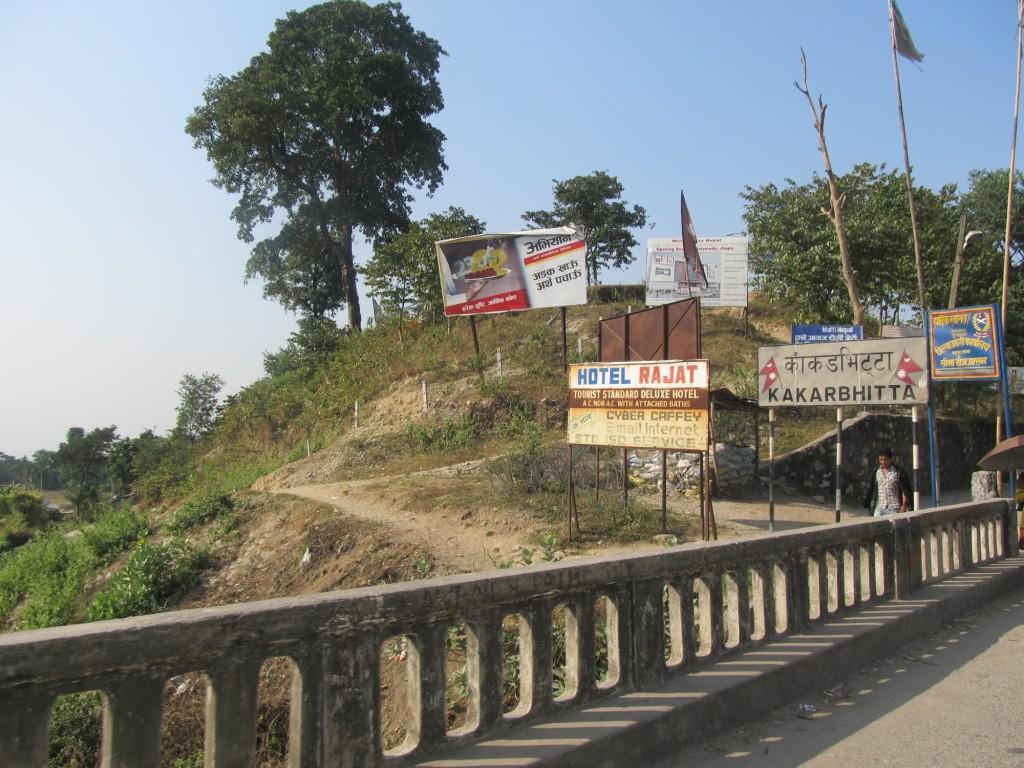What is the name of the hotel?
Ensure brevity in your answer.  Rajat. 